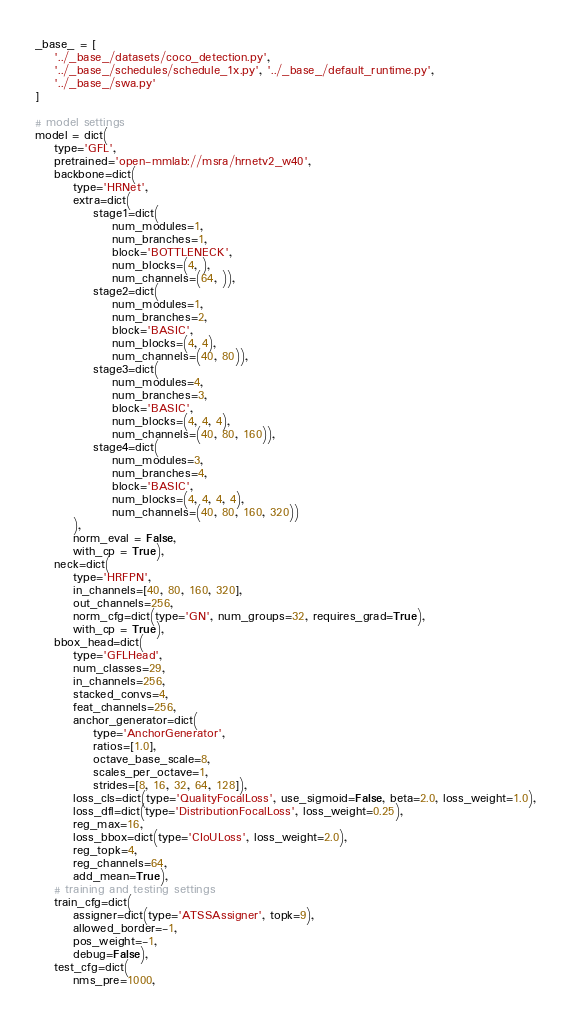Convert code to text. <code><loc_0><loc_0><loc_500><loc_500><_Python_>_base_ = [
	'../_base_/datasets/coco_detection.py',
	'../_base_/schedules/schedule_1x.py', '../_base_/default_runtime.py',
	'../_base_/swa.py'
]

# model settings
model = dict(
	type='GFL',
	pretrained='open-mmlab://msra/hrnetv2_w40',
	backbone=dict(
		type='HRNet',
		extra=dict(
			stage1=dict(
				num_modules=1,
				num_branches=1,
				block='BOTTLENECK',
				num_blocks=(4, ),
				num_channels=(64, )),
			stage2=dict(
				num_modules=1,
				num_branches=2,
				block='BASIC',
				num_blocks=(4, 4),
				num_channels=(40, 80)),
			stage3=dict(
				num_modules=4,
				num_branches=3,
				block='BASIC',
				num_blocks=(4, 4, 4),
				num_channels=(40, 80, 160)),
			stage4=dict(
				num_modules=3,
				num_branches=4,
				block='BASIC',
				num_blocks=(4, 4, 4, 4),
				num_channels=(40, 80, 160, 320))
		),
		norm_eval = False,
		with_cp = True),
	neck=dict(
		type='HRFPN',
		in_channels=[40, 80, 160, 320],
		out_channels=256,
		norm_cfg=dict(type='GN', num_groups=32, requires_grad=True),
		with_cp = True),
	bbox_head=dict(
		type='GFLHead',
		num_classes=29,
		in_channels=256,
		stacked_convs=4,
		feat_channels=256,
		anchor_generator=dict(
			type='AnchorGenerator',
			ratios=[1.0],
			octave_base_scale=8,
			scales_per_octave=1,
			strides=[8, 16, 32, 64, 128]),
		loss_cls=dict(type='QualityFocalLoss', use_sigmoid=False, beta=2.0, loss_weight=1.0),
		loss_dfl=dict(type='DistributionFocalLoss', loss_weight=0.25),
		reg_max=16,
		loss_bbox=dict(type='CIoULoss', loss_weight=2.0), 
		reg_topk=4,
		reg_channels=64,
		add_mean=True),
	# training and testing settings
	train_cfg=dict(
		assigner=dict(type='ATSSAssigner', topk=9),
		allowed_border=-1,
		pos_weight=-1,
		debug=False),
	test_cfg=dict(
		nms_pre=1000,</code> 